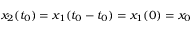Convert formula to latex. <formula><loc_0><loc_0><loc_500><loc_500>x _ { 2 } ( t _ { 0 } ) = x _ { 1 } ( t _ { 0 } - t _ { 0 } ) = x _ { 1 } ( 0 ) = x _ { 0 }</formula> 